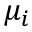<formula> <loc_0><loc_0><loc_500><loc_500>\mu _ { i }</formula> 